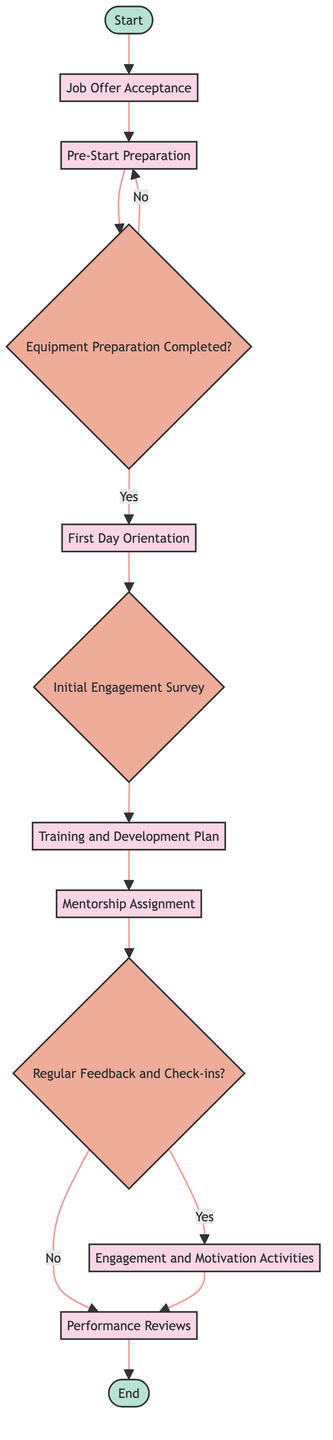What's the first step in the employee onboarding process? The diagram indicates that the first step is "Job Offer Acceptance," where the candidate accepts the job offer, initiating the onboarding process.
Answer: Job Offer Acceptance How many process nodes are present in the flowchart? By examining the diagram, I count a total of seven process nodes, which include Job Offer Acceptance, Pre-Start Preparation, First Day Orientation, Training and Development Plan, Mentorship Assignment, Engagement and Motivation Activities, and Performance Reviews.
Answer: Seven What happens if the equipment preparation is not completed? According to the flowchart, if equipment preparation is not completed, the flow directs back to "Pre-Start Preparation," indicating that the process will repeat until all necessary equipment is prepared.
Answer: Back to Pre-Start Preparation How many decision nodes are in the onboarding process? The diagram displays a total of four decision nodes, namely Equipment Preparation Completed, Initial Engagement Survey, Regular Feedback and Check-ins, and whether to perform Engagement and Motivation Activities or Performance Reviews.
Answer: Four What is the final step in the onboarding process? The diagram concludes with the node labeled "End," signaling that the onboarding process is complete, and ongoing support and development should continue.
Answer: End What is the relationship between the First Day Orientation and Initial Engagement Survey? The diagram shows that "First Day Orientation" directly leads to "Initial Engagement Survey," indicating that after the orientation is conducted, an engagement survey will be distributed.
Answer: Directly leads to What triggers the engagement and motivation activities? The flowchart indicates that "Engagement and Motivation Activities" are triggered if the answer to the "Regular Feedback and Check-ins?" decision node is "Yes," suggesting regular feedback is actively occurring.
Answer: Regular Feedback and Check-ins Yes Which two nodes are connected by a decision node that asks about equipment preparation? The diagram connects "Pre-Start Preparation" to "Equipment Preparation Completed?" and then directs to either "First Day Orientation" if yes, or back to "Pre-Start Preparation" if no.
Answer: Pre-Start Preparation and First Day Orientation 